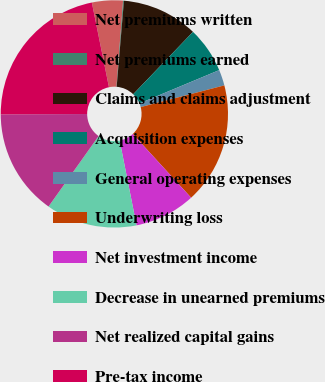Convert chart. <chart><loc_0><loc_0><loc_500><loc_500><pie_chart><fcel>Net premiums written<fcel>Net premiums earned<fcel>Claims and claims adjustment<fcel>Acquisition expenses<fcel>General operating expenses<fcel>Underwriting loss<fcel>Net investment income<fcel>Decrease in unearned premiums<fcel>Net realized capital gains<fcel>Pre-tax income<nl><fcel>4.4%<fcel>0.12%<fcel>10.82%<fcel>6.54%<fcel>2.26%<fcel>17.24%<fcel>8.68%<fcel>12.96%<fcel>15.1%<fcel>21.9%<nl></chart> 